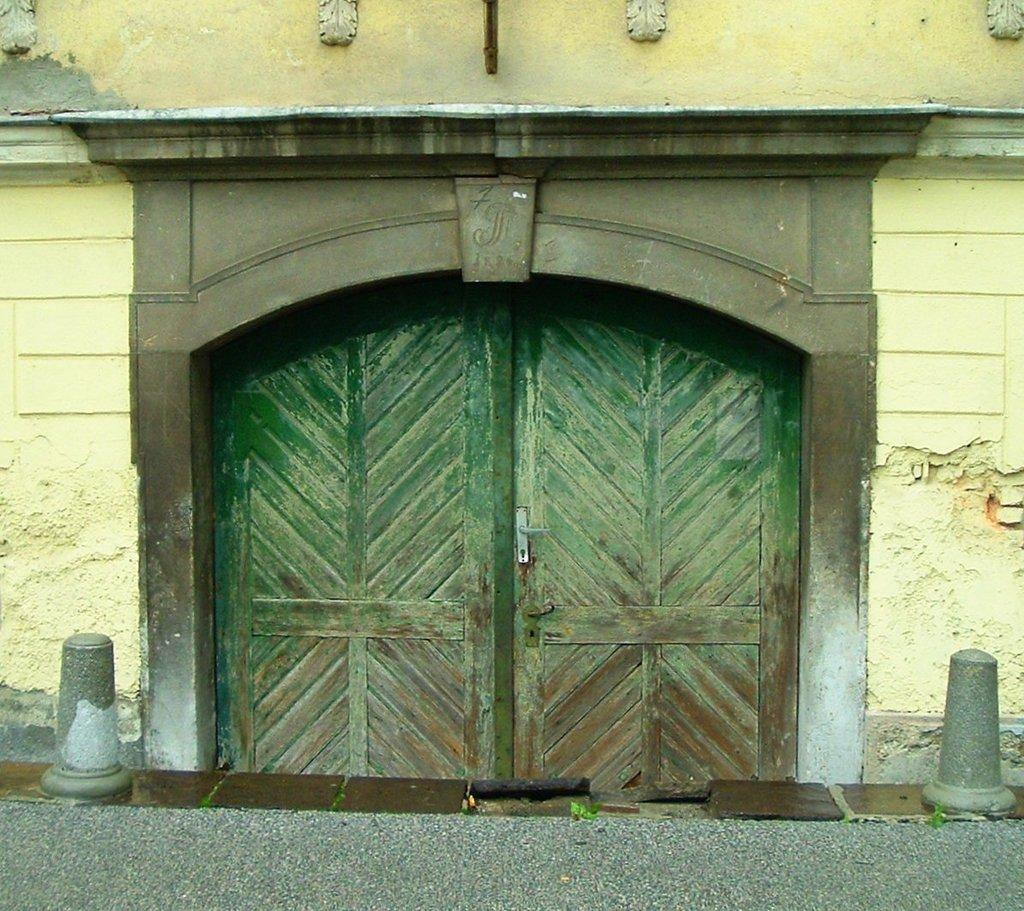What type of structure is present in the image? There is a building in the image. What feature of the building is visible in the image? There are doors visible in the image. What is the path in the image used for? The path in the image is likely used for walking or navigating the area. What type of shade is provided by the birthday celebration in the image? There is no birthday celebration or shade mentioned in the image; it only features a building, doors, and a path. 